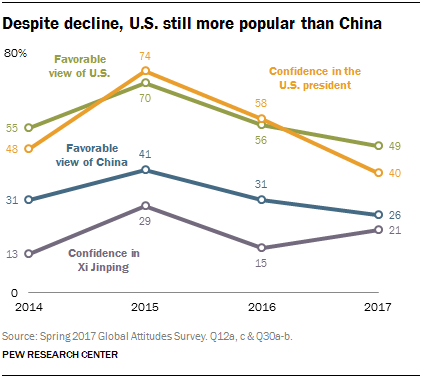Mention a couple of crucial points in this snapshot. The favorable view of the United States reached its peak in 2015. For how many times has the favorable view of the United States been over 50%? 3 times. 